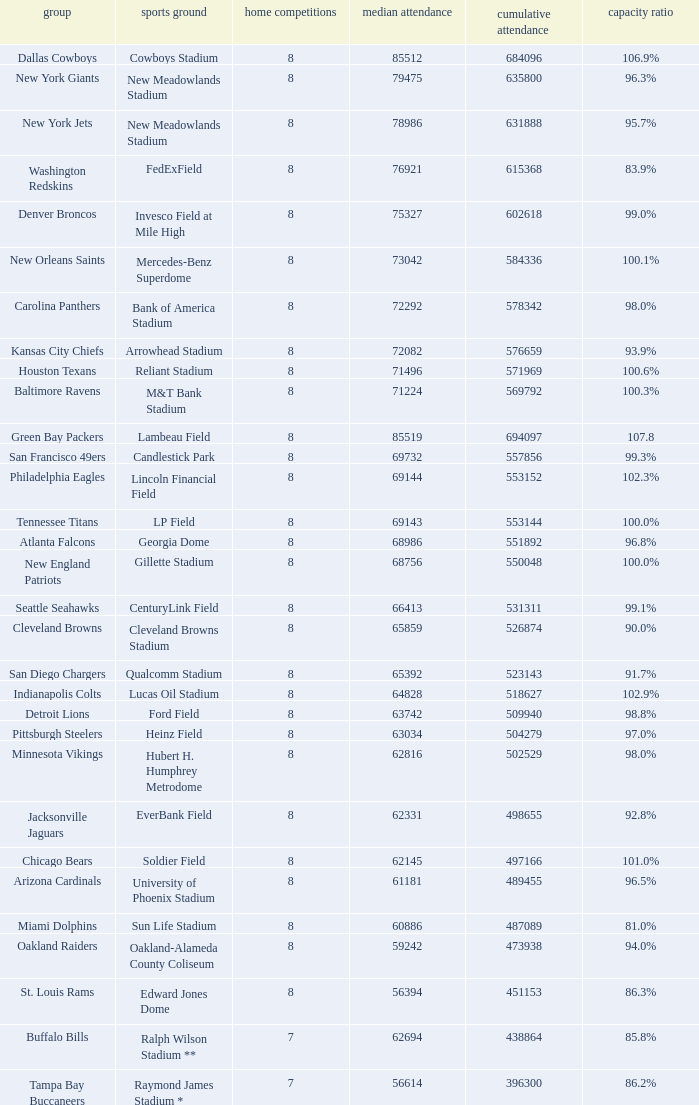What is the name of the stadium when the capacity percentage is 83.9% FedExField. 